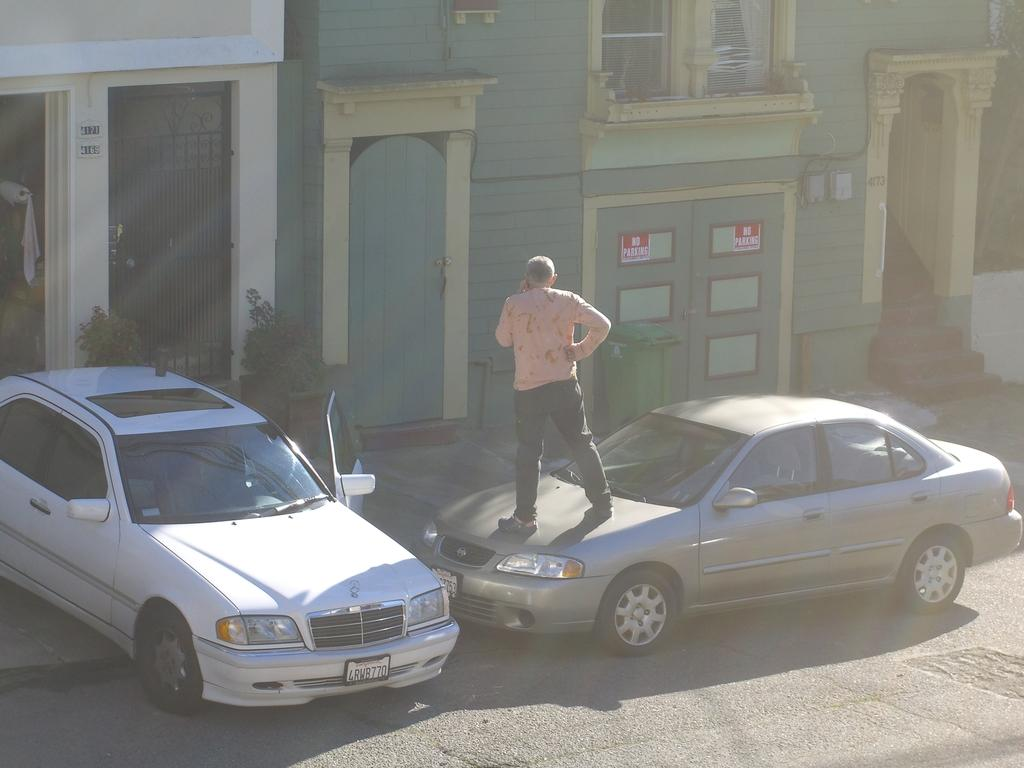How many cars are present in the image? There are two cars in the image. What is the person in the image doing? There is a person standing on one of the cars. What type of structures can be seen in the background of the image? There are homes visible in the image. What type of test is being conducted at the airport in the image? There is no airport or test present in the image; it features two cars and a person standing on one of them. 